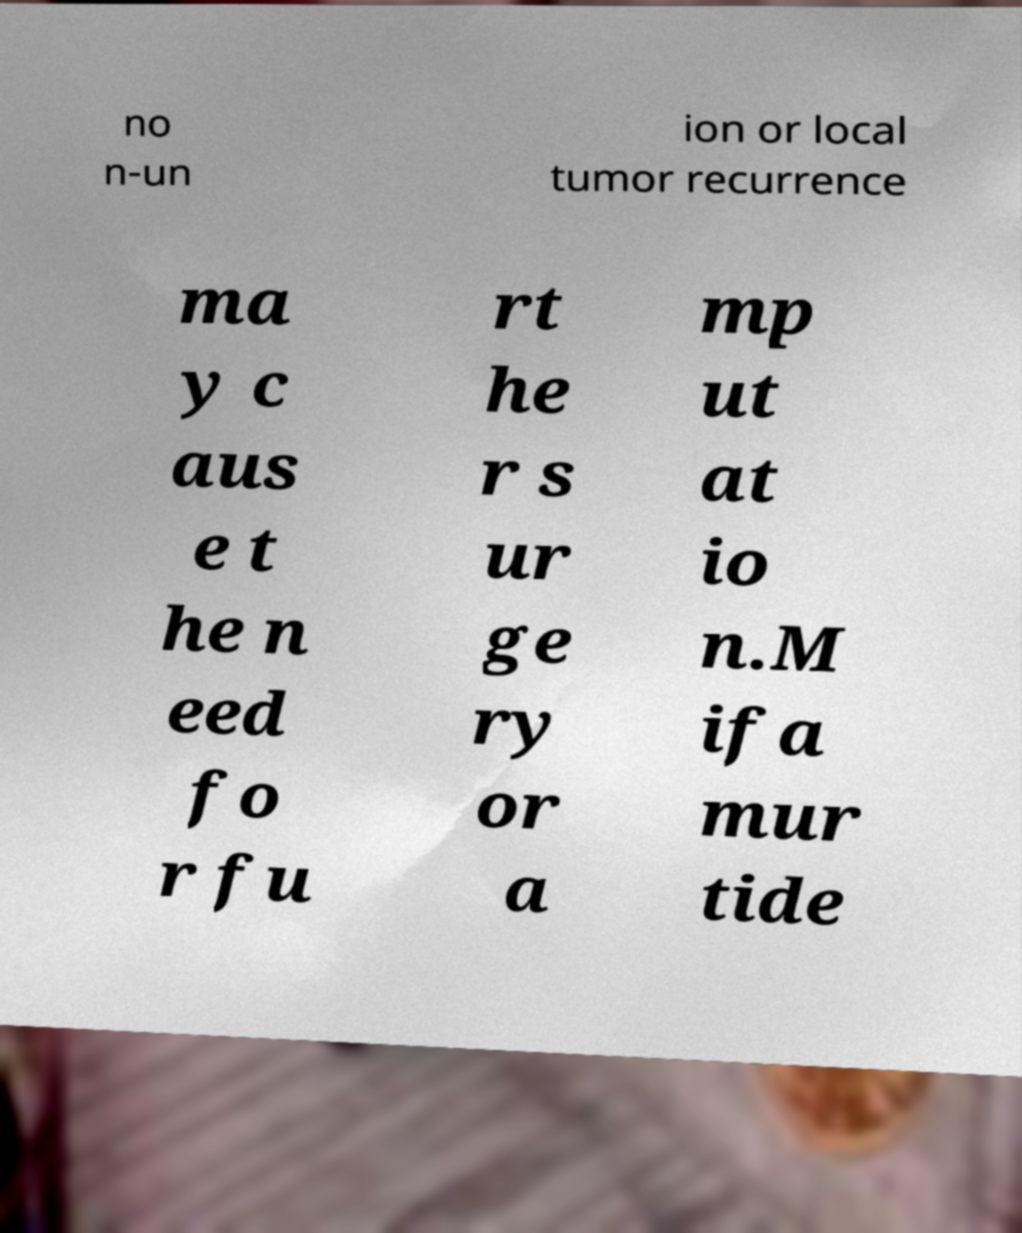Could you extract and type out the text from this image? no n-un ion or local tumor recurrence ma y c aus e t he n eed fo r fu rt he r s ur ge ry or a mp ut at io n.M ifa mur tide 